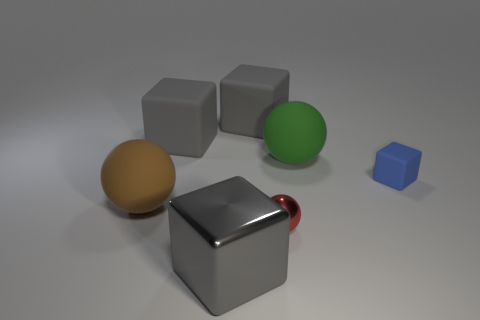How many gray blocks must be subtracted to get 1 gray blocks? 2 Subtract all gray cylinders. How many gray cubes are left? 3 Subtract all gray shiny blocks. How many blocks are left? 3 Subtract 1 cubes. How many cubes are left? 3 Add 3 small blue objects. How many objects exist? 10 Subtract all blue blocks. How many blocks are left? 3 Subtract all spheres. How many objects are left? 4 Subtract 0 yellow blocks. How many objects are left? 7 Subtract all yellow balls. Subtract all blue cylinders. How many balls are left? 3 Subtract all green things. Subtract all green spheres. How many objects are left? 5 